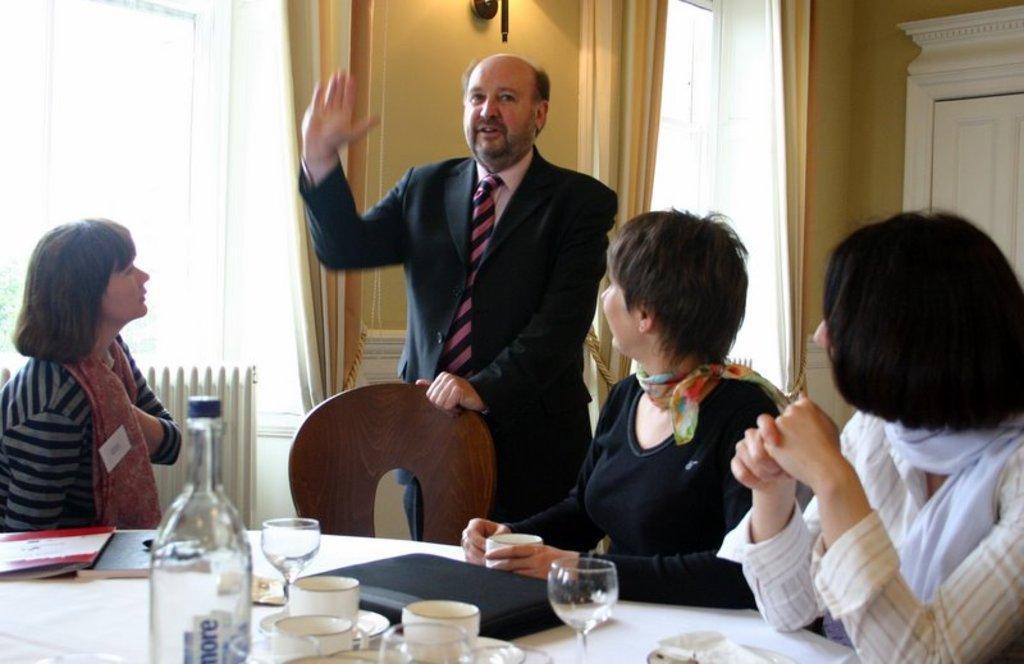Please provide a concise description of this image. In the image we can see there are people who are sitting on chair and there is a man who is standing and on table we can see there is a bottle, wine glass, cup and soccer. 